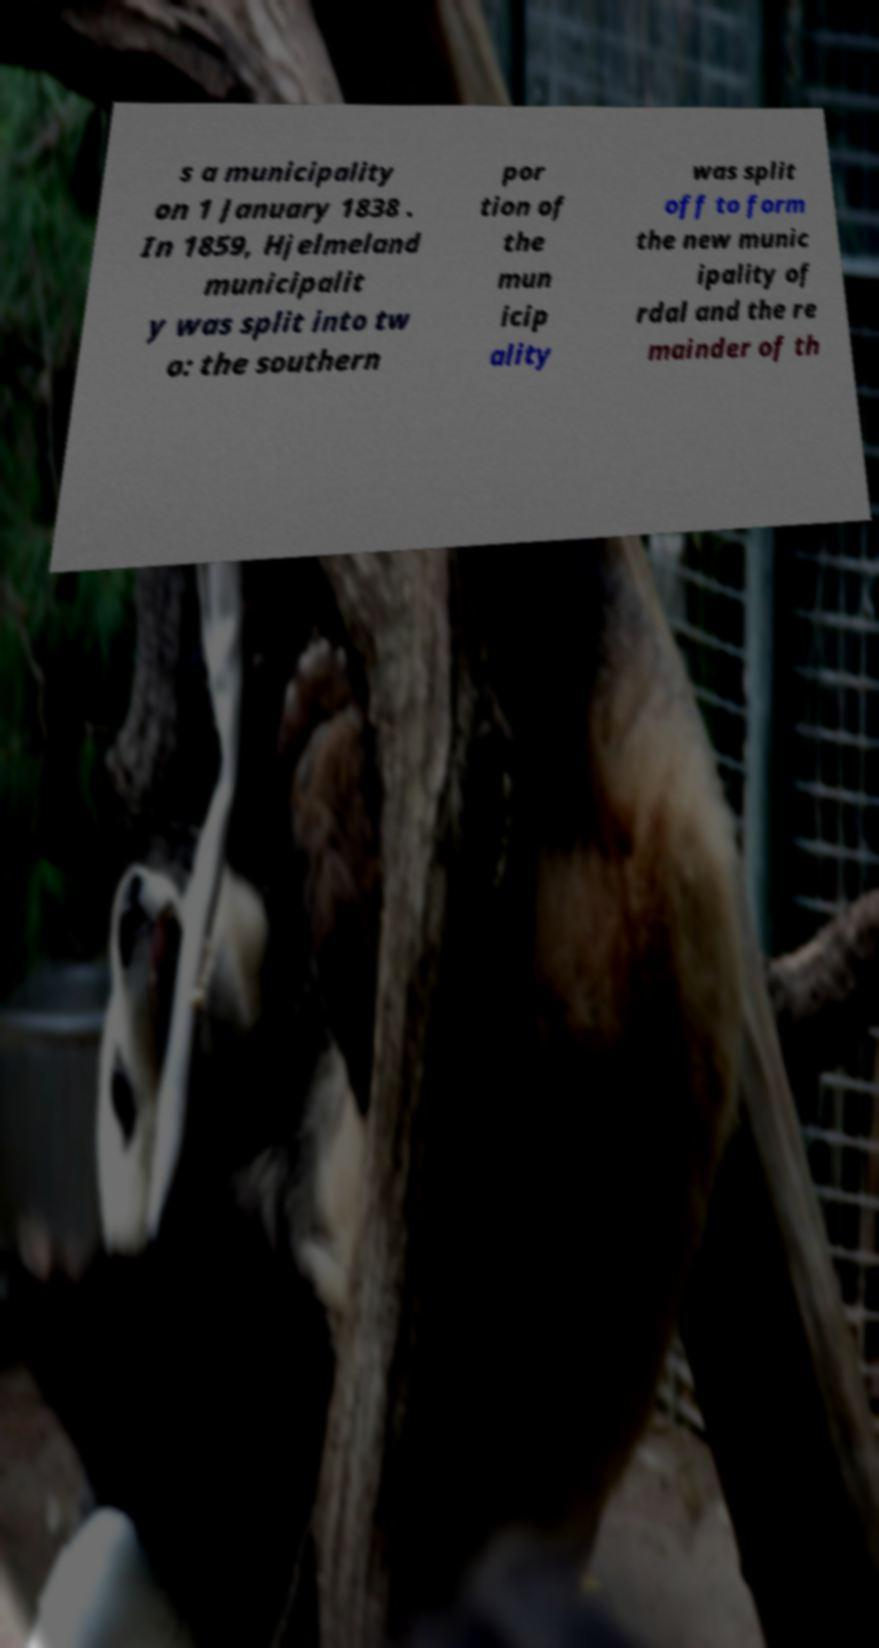What messages or text are displayed in this image? I need them in a readable, typed format. s a municipality on 1 January 1838 . In 1859, Hjelmeland municipalit y was split into tw o: the southern por tion of the mun icip ality was split off to form the new munic ipality of rdal and the re mainder of th 